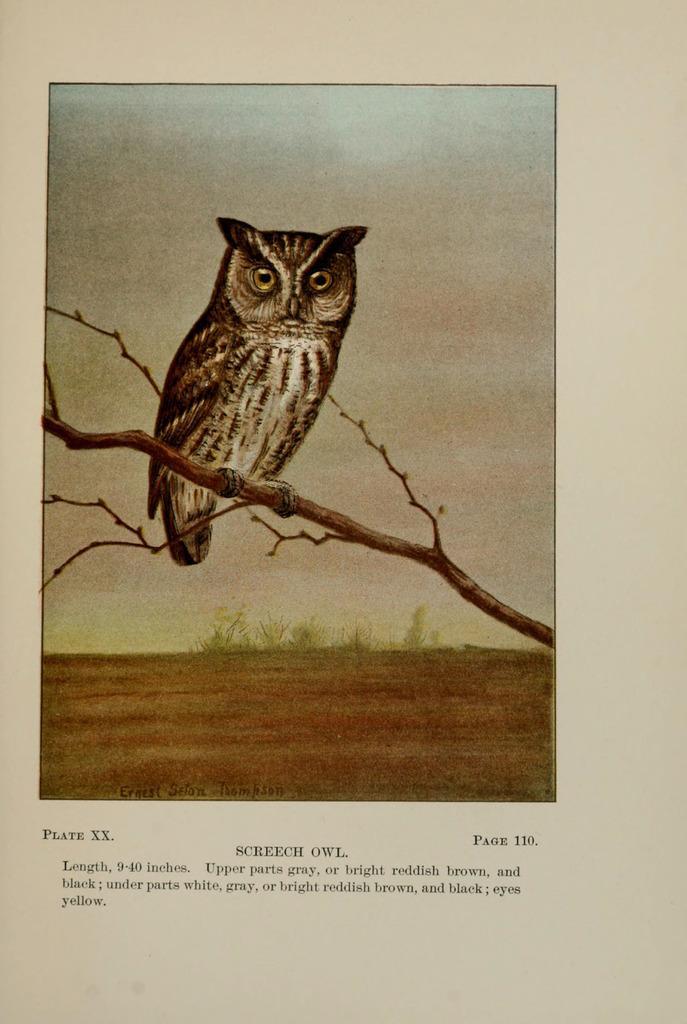Describe this image in one or two sentences. In this picture we can see a painting of an owl sitting on the branch of a tree. In the background we can see the sky and some plants and the ground. At the bottom we can see the text on the image. 